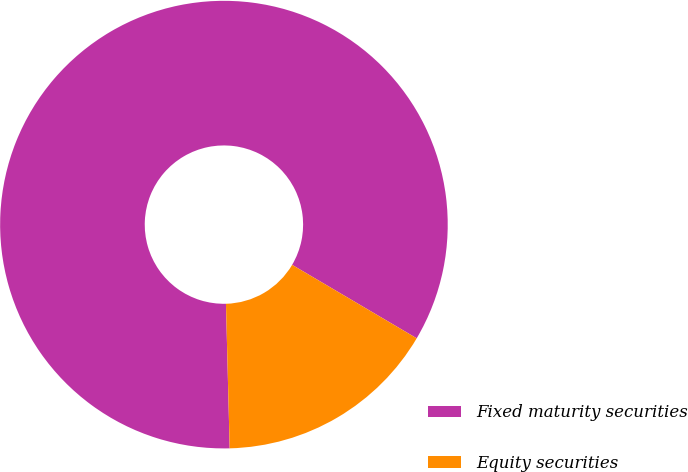Convert chart. <chart><loc_0><loc_0><loc_500><loc_500><pie_chart><fcel>Fixed maturity securities<fcel>Equity securities<nl><fcel>83.89%<fcel>16.11%<nl></chart> 